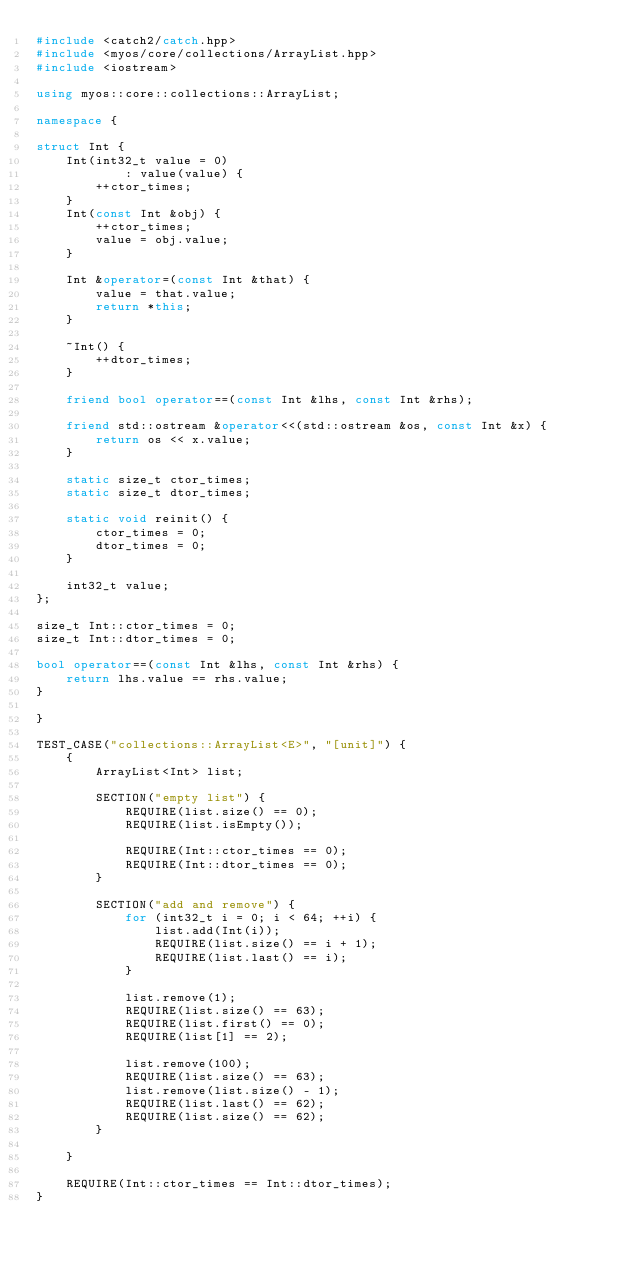<code> <loc_0><loc_0><loc_500><loc_500><_C++_>#include <catch2/catch.hpp>
#include <myos/core/collections/ArrayList.hpp>
#include <iostream>

using myos::core::collections::ArrayList;

namespace {

struct Int {
    Int(int32_t value = 0)
            : value(value) {
        ++ctor_times;
    }
    Int(const Int &obj) {
        ++ctor_times;
        value = obj.value;
    }

    Int &operator=(const Int &that) {
        value = that.value;
        return *this;
    }

    ~Int() {
        ++dtor_times;
    }

    friend bool operator==(const Int &lhs, const Int &rhs);

    friend std::ostream &operator<<(std::ostream &os, const Int &x) {
        return os << x.value;
    }

    static size_t ctor_times;
    static size_t dtor_times;

    static void reinit() {
        ctor_times = 0;
        dtor_times = 0;
    }

    int32_t value;
};

size_t Int::ctor_times = 0;
size_t Int::dtor_times = 0;

bool operator==(const Int &lhs, const Int &rhs) {
    return lhs.value == rhs.value;
}

}

TEST_CASE("collections::ArrayList<E>", "[unit]") {
    {
        ArrayList<Int> list;

        SECTION("empty list") {
            REQUIRE(list.size() == 0);
            REQUIRE(list.isEmpty());

            REQUIRE(Int::ctor_times == 0);
            REQUIRE(Int::dtor_times == 0);
        }

        SECTION("add and remove") {
            for (int32_t i = 0; i < 64; ++i) {
                list.add(Int(i));
                REQUIRE(list.size() == i + 1);
                REQUIRE(list.last() == i);
            }

            list.remove(1);
            REQUIRE(list.size() == 63);
            REQUIRE(list.first() == 0);
            REQUIRE(list[1] == 2);

            list.remove(100);
            REQUIRE(list.size() == 63);
            list.remove(list.size() - 1);
            REQUIRE(list.last() == 62);
            REQUIRE(list.size() == 62);
        }

    }

    REQUIRE(Int::ctor_times == Int::dtor_times);
}
</code> 